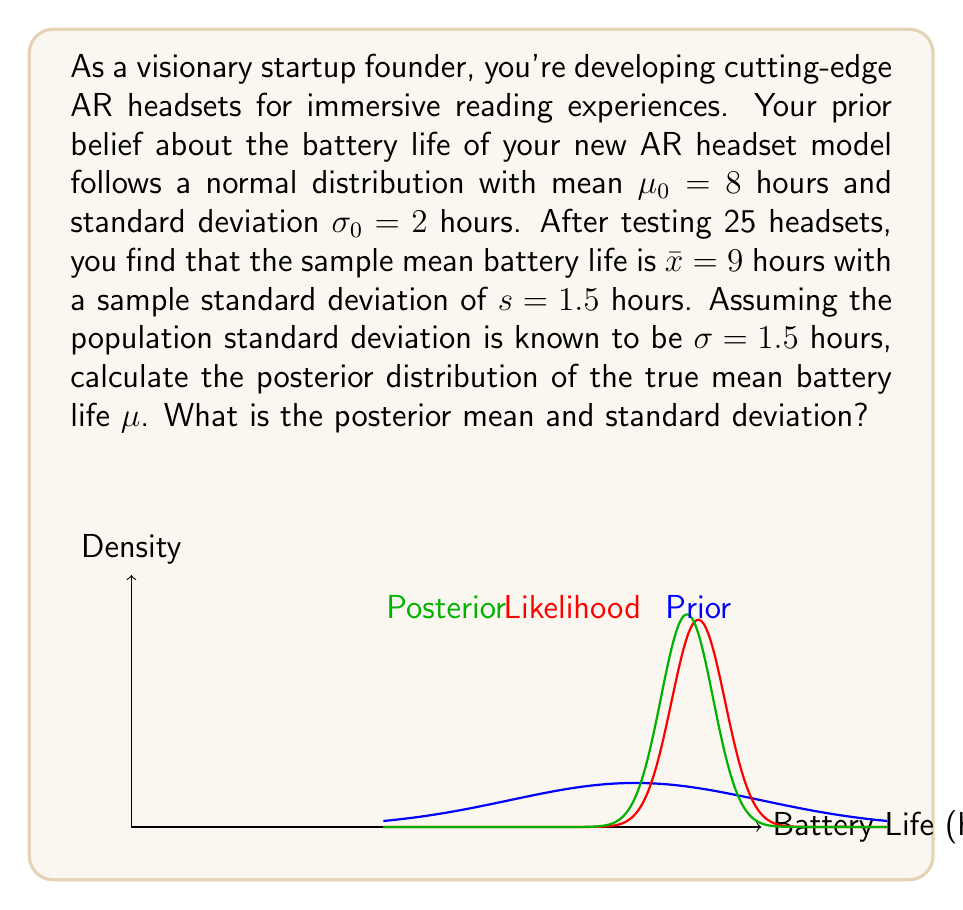Could you help me with this problem? To solve this Bayesian problem, we'll use the normal-normal conjugate prior model. Let's follow these steps:

1) Prior distribution: $\mu \sim N(\mu_0, \sigma_0^2)$ where $\mu_0 = 8$ and $\sigma_0 = 2$

2) Likelihood: $X_i \sim N(\mu, \sigma^2)$ where $\sigma = 1.5$, $n = 25$, and $\bar{x} = 9$

3) For the normal-normal model, the posterior distribution is also normal:

   $\mu | x \sim N(\mu_n, \sigma_n^2)$

4) The posterior mean $\mu_n$ is a weighted average of the prior mean and the sample mean:

   $$\mu_n = \frac{\frac{\mu_0}{\sigma_0^2} + \frac{n\bar{x}}{\sigma^2}}{\frac{1}{\sigma_0^2} + \frac{n}{\sigma^2}}$$

5) The posterior precision (inverse of variance) is the sum of the prior and data precisions:

   $$\frac{1}{\sigma_n^2} = \frac{1}{\sigma_0^2} + \frac{n}{\sigma^2}$$

6) Let's calculate the posterior mean:

   $$\mu_n = \frac{\frac{8}{2^2} + \frac{25 \cdot 9}{1.5^2}}{\frac{1}{2^2} + \frac{25}{1.5^2}} = \frac{2 + 100}{0.25 + 11.11} \approx 8.82$$

7) Now, let's calculate the posterior standard deviation:

   $$\frac{1}{\sigma_n^2} = \frac{1}{2^2} + \frac{25}{1.5^2} = 0.25 + 11.11 = 11.36$$
   $$\sigma_n^2 = \frac{1}{11.36} \approx 0.088$$
   $$\sigma_n = \sqrt{0.088} \approx 0.297$$

Therefore, the posterior distribution is $N(8.82, 0.297^2)$.
Answer: $\mu | x \sim N(8.82, 0.297^2)$ 